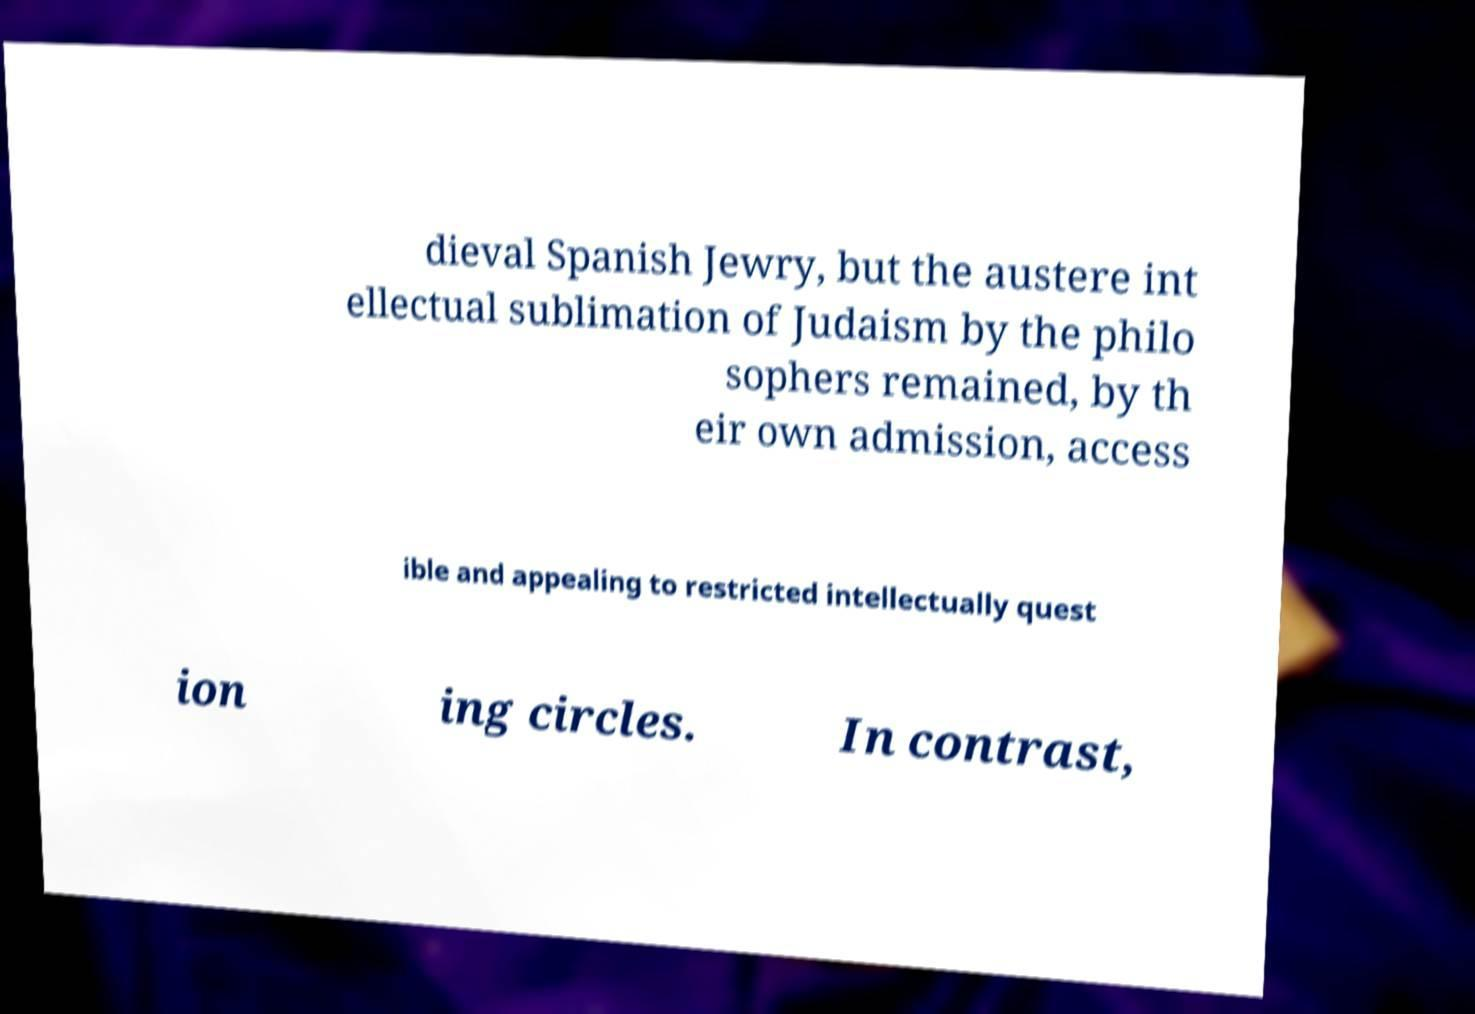Please identify and transcribe the text found in this image. dieval Spanish Jewry, but the austere int ellectual sublimation of Judaism by the philo sophers remained, by th eir own admission, access ible and appealing to restricted intellectually quest ion ing circles. In contrast, 